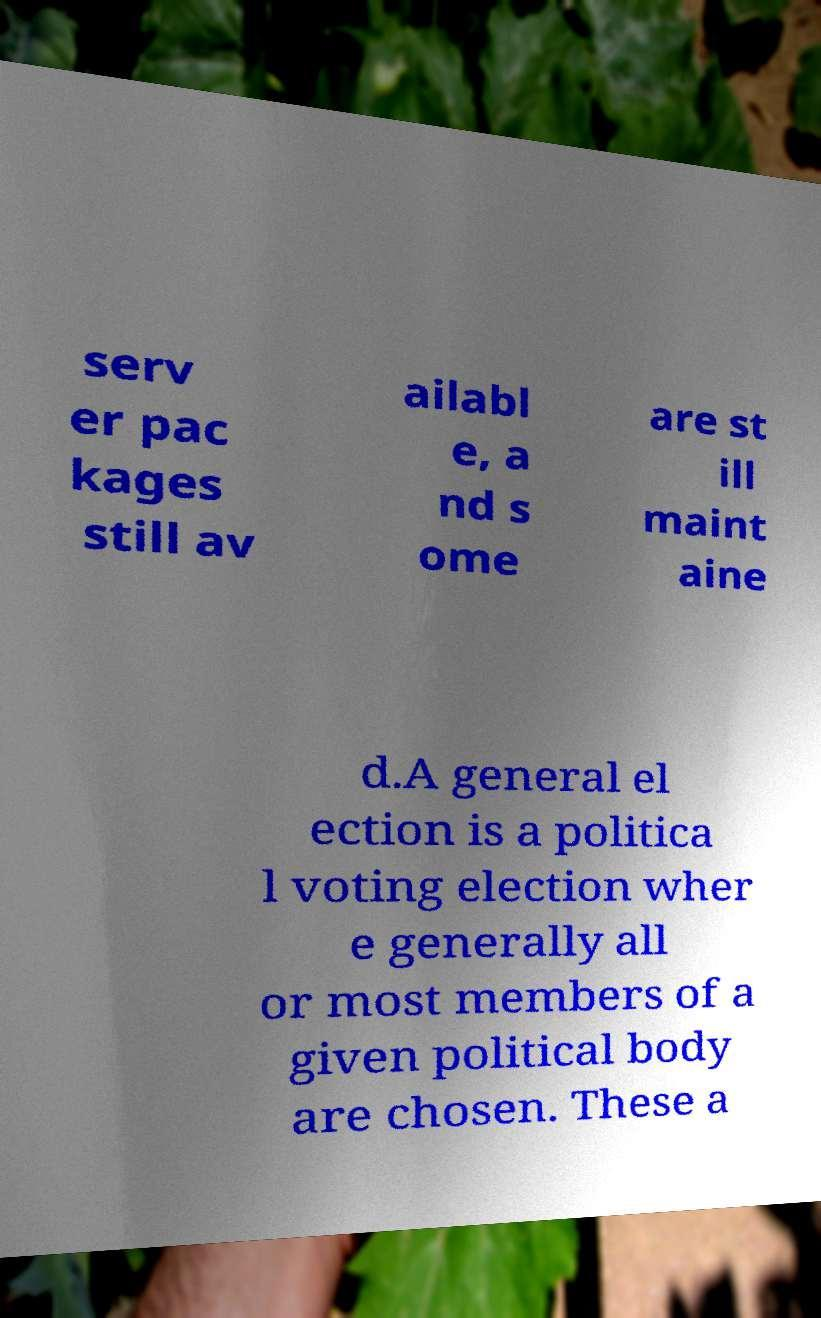There's text embedded in this image that I need extracted. Can you transcribe it verbatim? serv er pac kages still av ailabl e, a nd s ome are st ill maint aine d.A general el ection is a politica l voting election wher e generally all or most members of a given political body are chosen. These a 